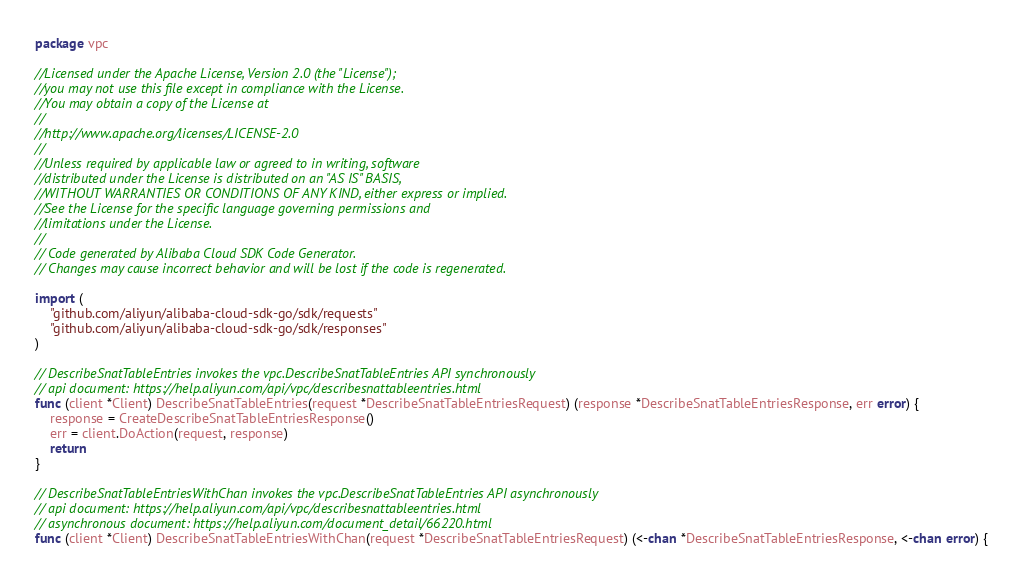<code> <loc_0><loc_0><loc_500><loc_500><_Go_>package vpc

//Licensed under the Apache License, Version 2.0 (the "License");
//you may not use this file except in compliance with the License.
//You may obtain a copy of the License at
//
//http://www.apache.org/licenses/LICENSE-2.0
//
//Unless required by applicable law or agreed to in writing, software
//distributed under the License is distributed on an "AS IS" BASIS,
//WITHOUT WARRANTIES OR CONDITIONS OF ANY KIND, either express or implied.
//See the License for the specific language governing permissions and
//limitations under the License.
//
// Code generated by Alibaba Cloud SDK Code Generator.
// Changes may cause incorrect behavior and will be lost if the code is regenerated.

import (
	"github.com/aliyun/alibaba-cloud-sdk-go/sdk/requests"
	"github.com/aliyun/alibaba-cloud-sdk-go/sdk/responses"
)

// DescribeSnatTableEntries invokes the vpc.DescribeSnatTableEntries API synchronously
// api document: https://help.aliyun.com/api/vpc/describesnattableentries.html
func (client *Client) DescribeSnatTableEntries(request *DescribeSnatTableEntriesRequest) (response *DescribeSnatTableEntriesResponse, err error) {
	response = CreateDescribeSnatTableEntriesResponse()
	err = client.DoAction(request, response)
	return
}

// DescribeSnatTableEntriesWithChan invokes the vpc.DescribeSnatTableEntries API asynchronously
// api document: https://help.aliyun.com/api/vpc/describesnattableentries.html
// asynchronous document: https://help.aliyun.com/document_detail/66220.html
func (client *Client) DescribeSnatTableEntriesWithChan(request *DescribeSnatTableEntriesRequest) (<-chan *DescribeSnatTableEntriesResponse, <-chan error) {</code> 